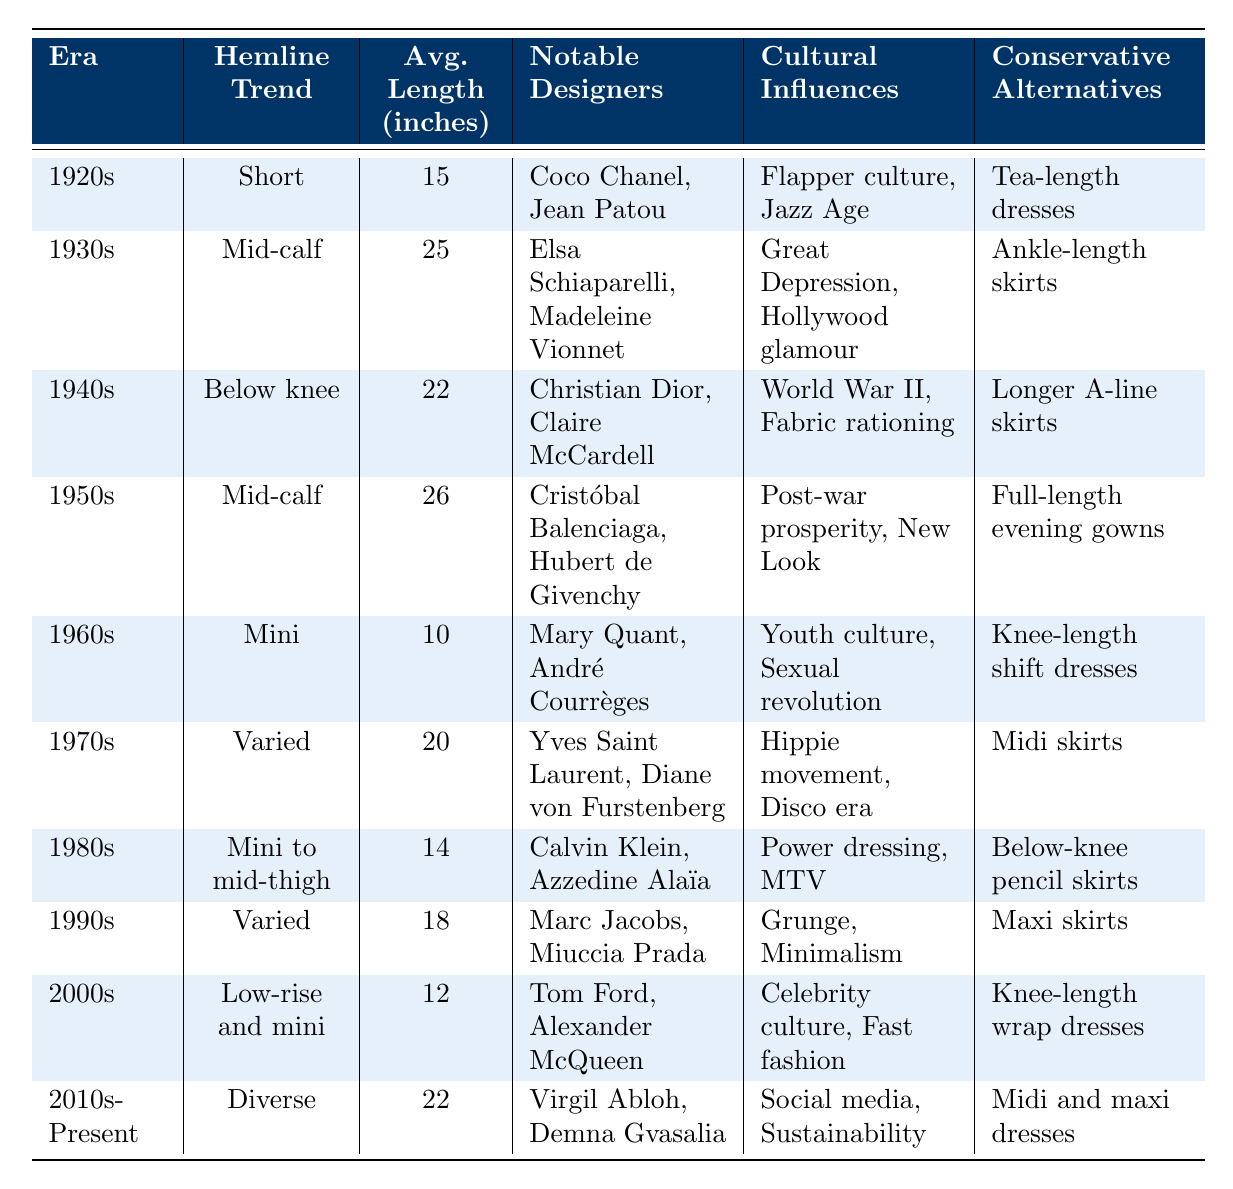What was the average hemline length during the 1950s? The table indicates the average hemline length for the 1950s was 26 inches.
Answer: 26 inches Which era had the shortest average hemline length? Referring to the table, the 1960s had the shortest average hemline length of 10 inches.
Answer: 1960s Were tea-length dresses popular in the 1930s? The table states that tea-length dresses were conservative alternatives during the 1920s, not the 1930s.
Answer: No Which decade saw a significant influence from the youth culture? According to the cultural influences listed, the 1960s were marked by the youth culture, which aligns with the mini hemline trend of that era.
Answer: 1960s How many inches longer was the average hemline in the 1930s compared to the 1960s? The average length for the 1930s is 25 inches, while for the 1960s it is 10 inches. Subtracting gives 25 - 10 = 15 inches longer.
Answer: 15 inches What is the hemline trend in the 2010s to the present? The table shows that the hemline trend from the 2010s to the present is categorized as diverse.
Answer: Diverse Which notable designers were associated with the 1940s? From the table, Christian Dior and Claire McCardell were the notable designers for the 1940s.
Answer: Christian Dior, Claire McCardell Was the cultural influence of the 1990s aligned more with grunge or post-war prosperity? The table indicates that the 1990s were influenced by grunge, while post-war prosperity was associated with the 1950s.
Answer: Grunge Calculate the average hemline length across all decades listed in the table. To find the average, sum all the average lengths: 15 + 25 + 22 + 26 + 10 + 20 + 14 + 18 + 12 + 22 =  20.2 inches divided by 10 data points gives the average of 20.2 inches.
Answer: 20.2 inches Was there a noticeable increase or decrease in average hemline length from the 1980s to the 1990s? In the table, the average length for the 1980s is 14 inches, while for the 1990s it is 18 inches, indicating an increase of 4 inches.
Answer: Increase 